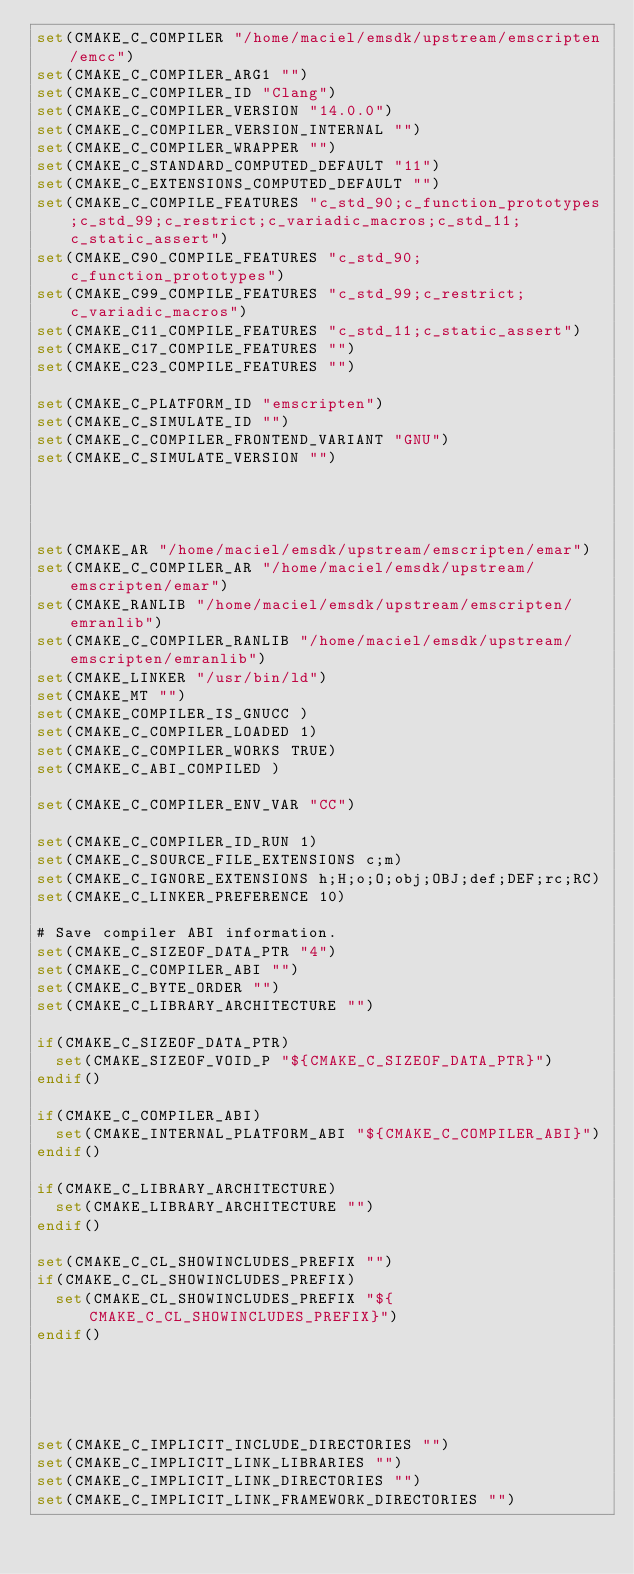<code> <loc_0><loc_0><loc_500><loc_500><_CMake_>set(CMAKE_C_COMPILER "/home/maciel/emsdk/upstream/emscripten/emcc")
set(CMAKE_C_COMPILER_ARG1 "")
set(CMAKE_C_COMPILER_ID "Clang")
set(CMAKE_C_COMPILER_VERSION "14.0.0")
set(CMAKE_C_COMPILER_VERSION_INTERNAL "")
set(CMAKE_C_COMPILER_WRAPPER "")
set(CMAKE_C_STANDARD_COMPUTED_DEFAULT "11")
set(CMAKE_C_EXTENSIONS_COMPUTED_DEFAULT "")
set(CMAKE_C_COMPILE_FEATURES "c_std_90;c_function_prototypes;c_std_99;c_restrict;c_variadic_macros;c_std_11;c_static_assert")
set(CMAKE_C90_COMPILE_FEATURES "c_std_90;c_function_prototypes")
set(CMAKE_C99_COMPILE_FEATURES "c_std_99;c_restrict;c_variadic_macros")
set(CMAKE_C11_COMPILE_FEATURES "c_std_11;c_static_assert")
set(CMAKE_C17_COMPILE_FEATURES "")
set(CMAKE_C23_COMPILE_FEATURES "")

set(CMAKE_C_PLATFORM_ID "emscripten")
set(CMAKE_C_SIMULATE_ID "")
set(CMAKE_C_COMPILER_FRONTEND_VARIANT "GNU")
set(CMAKE_C_SIMULATE_VERSION "")




set(CMAKE_AR "/home/maciel/emsdk/upstream/emscripten/emar")
set(CMAKE_C_COMPILER_AR "/home/maciel/emsdk/upstream/emscripten/emar")
set(CMAKE_RANLIB "/home/maciel/emsdk/upstream/emscripten/emranlib")
set(CMAKE_C_COMPILER_RANLIB "/home/maciel/emsdk/upstream/emscripten/emranlib")
set(CMAKE_LINKER "/usr/bin/ld")
set(CMAKE_MT "")
set(CMAKE_COMPILER_IS_GNUCC )
set(CMAKE_C_COMPILER_LOADED 1)
set(CMAKE_C_COMPILER_WORKS TRUE)
set(CMAKE_C_ABI_COMPILED )

set(CMAKE_C_COMPILER_ENV_VAR "CC")

set(CMAKE_C_COMPILER_ID_RUN 1)
set(CMAKE_C_SOURCE_FILE_EXTENSIONS c;m)
set(CMAKE_C_IGNORE_EXTENSIONS h;H;o;O;obj;OBJ;def;DEF;rc;RC)
set(CMAKE_C_LINKER_PREFERENCE 10)

# Save compiler ABI information.
set(CMAKE_C_SIZEOF_DATA_PTR "4")
set(CMAKE_C_COMPILER_ABI "")
set(CMAKE_C_BYTE_ORDER "")
set(CMAKE_C_LIBRARY_ARCHITECTURE "")

if(CMAKE_C_SIZEOF_DATA_PTR)
  set(CMAKE_SIZEOF_VOID_P "${CMAKE_C_SIZEOF_DATA_PTR}")
endif()

if(CMAKE_C_COMPILER_ABI)
  set(CMAKE_INTERNAL_PLATFORM_ABI "${CMAKE_C_COMPILER_ABI}")
endif()

if(CMAKE_C_LIBRARY_ARCHITECTURE)
  set(CMAKE_LIBRARY_ARCHITECTURE "")
endif()

set(CMAKE_C_CL_SHOWINCLUDES_PREFIX "")
if(CMAKE_C_CL_SHOWINCLUDES_PREFIX)
  set(CMAKE_CL_SHOWINCLUDES_PREFIX "${CMAKE_C_CL_SHOWINCLUDES_PREFIX}")
endif()





set(CMAKE_C_IMPLICIT_INCLUDE_DIRECTORIES "")
set(CMAKE_C_IMPLICIT_LINK_LIBRARIES "")
set(CMAKE_C_IMPLICIT_LINK_DIRECTORIES "")
set(CMAKE_C_IMPLICIT_LINK_FRAMEWORK_DIRECTORIES "")
</code> 